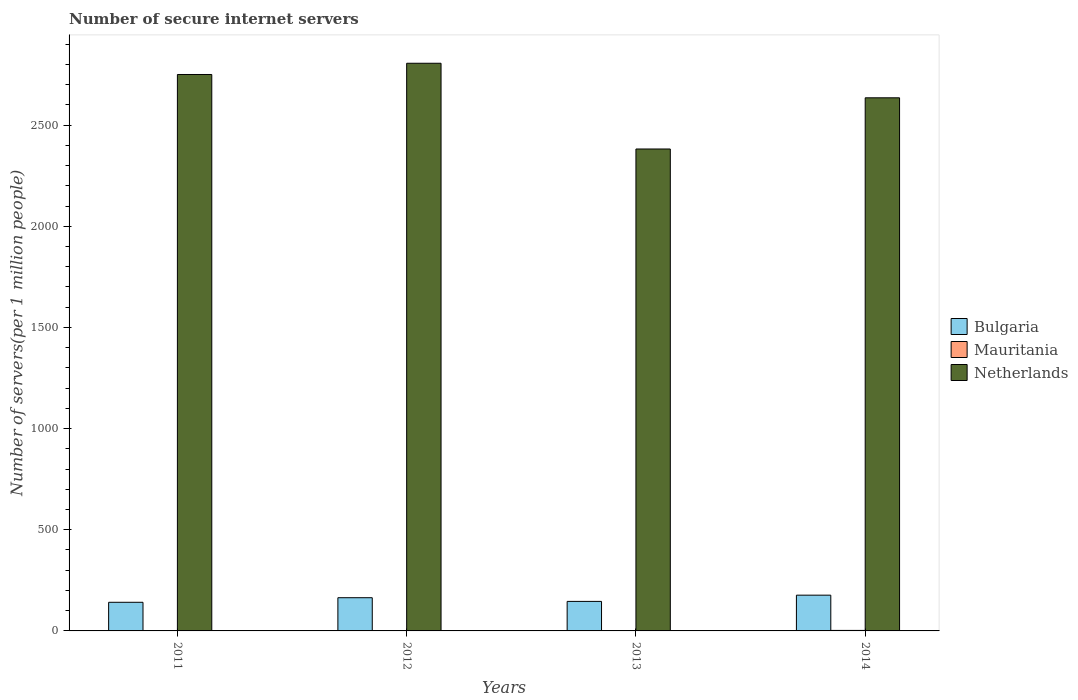How many different coloured bars are there?
Your answer should be very brief. 3. How many bars are there on the 4th tick from the left?
Offer a very short reply. 3. What is the number of secure internet servers in Bulgaria in 2014?
Keep it short and to the point. 176.72. Across all years, what is the maximum number of secure internet servers in Bulgaria?
Ensure brevity in your answer.  176.72. Across all years, what is the minimum number of secure internet servers in Bulgaria?
Make the answer very short. 141.53. What is the total number of secure internet servers in Mauritania in the graph?
Offer a terse response. 8.34. What is the difference between the number of secure internet servers in Bulgaria in 2012 and that in 2013?
Give a very brief answer. 18.21. What is the difference between the number of secure internet servers in Netherlands in 2014 and the number of secure internet servers in Mauritania in 2013?
Offer a very short reply. 2633.01. What is the average number of secure internet servers in Bulgaria per year?
Your answer should be compact. 157.07. In the year 2014, what is the difference between the number of secure internet servers in Bulgaria and number of secure internet servers in Netherlands?
Offer a very short reply. -2458.36. In how many years, is the number of secure internet servers in Mauritania greater than 2500?
Provide a short and direct response. 0. What is the ratio of the number of secure internet servers in Mauritania in 2011 to that in 2014?
Provide a succinct answer. 0.75. Is the number of secure internet servers in Bulgaria in 2012 less than that in 2013?
Provide a succinct answer. No. Is the difference between the number of secure internet servers in Bulgaria in 2012 and 2013 greater than the difference between the number of secure internet servers in Netherlands in 2012 and 2013?
Provide a short and direct response. No. What is the difference between the highest and the second highest number of secure internet servers in Mauritania?
Provide a succinct answer. 0.45. What is the difference between the highest and the lowest number of secure internet servers in Bulgaria?
Your answer should be very brief. 35.19. What does the 2nd bar from the left in 2011 represents?
Offer a terse response. Mauritania. What does the 2nd bar from the right in 2011 represents?
Offer a very short reply. Mauritania. Is it the case that in every year, the sum of the number of secure internet servers in Mauritania and number of secure internet servers in Bulgaria is greater than the number of secure internet servers in Netherlands?
Offer a terse response. No. How many bars are there?
Your answer should be very brief. 12. Are all the bars in the graph horizontal?
Keep it short and to the point. No. Does the graph contain any zero values?
Your answer should be compact. No. What is the title of the graph?
Your answer should be compact. Number of secure internet servers. Does "Faeroe Islands" appear as one of the legend labels in the graph?
Offer a terse response. No. What is the label or title of the Y-axis?
Your response must be concise. Number of servers(per 1 million people). What is the Number of servers(per 1 million people) of Bulgaria in 2011?
Make the answer very short. 141.53. What is the Number of servers(per 1 million people) in Mauritania in 2011?
Your response must be concise. 1.9. What is the Number of servers(per 1 million people) in Netherlands in 2011?
Make the answer very short. 2750.3. What is the Number of servers(per 1 million people) in Bulgaria in 2012?
Offer a terse response. 164.11. What is the Number of servers(per 1 million people) of Mauritania in 2012?
Provide a succinct answer. 1.85. What is the Number of servers(per 1 million people) of Netherlands in 2012?
Your response must be concise. 2805.86. What is the Number of servers(per 1 million people) of Bulgaria in 2013?
Your answer should be compact. 145.9. What is the Number of servers(per 1 million people) of Mauritania in 2013?
Your answer should be very brief. 2.07. What is the Number of servers(per 1 million people) of Netherlands in 2013?
Your answer should be compact. 2382.11. What is the Number of servers(per 1 million people) of Bulgaria in 2014?
Give a very brief answer. 176.72. What is the Number of servers(per 1 million people) of Mauritania in 2014?
Provide a succinct answer. 2.52. What is the Number of servers(per 1 million people) of Netherlands in 2014?
Your answer should be compact. 2635.07. Across all years, what is the maximum Number of servers(per 1 million people) in Bulgaria?
Your answer should be very brief. 176.72. Across all years, what is the maximum Number of servers(per 1 million people) of Mauritania?
Offer a terse response. 2.52. Across all years, what is the maximum Number of servers(per 1 million people) of Netherlands?
Offer a very short reply. 2805.86. Across all years, what is the minimum Number of servers(per 1 million people) in Bulgaria?
Ensure brevity in your answer.  141.53. Across all years, what is the minimum Number of servers(per 1 million people) in Mauritania?
Make the answer very short. 1.85. Across all years, what is the minimum Number of servers(per 1 million people) of Netherlands?
Give a very brief answer. 2382.11. What is the total Number of servers(per 1 million people) in Bulgaria in the graph?
Your answer should be compact. 628.26. What is the total Number of servers(per 1 million people) of Mauritania in the graph?
Keep it short and to the point. 8.34. What is the total Number of servers(per 1 million people) in Netherlands in the graph?
Provide a short and direct response. 1.06e+04. What is the difference between the Number of servers(per 1 million people) in Bulgaria in 2011 and that in 2012?
Ensure brevity in your answer.  -22.59. What is the difference between the Number of servers(per 1 million people) in Mauritania in 2011 and that in 2012?
Your answer should be compact. 0.05. What is the difference between the Number of servers(per 1 million people) in Netherlands in 2011 and that in 2012?
Offer a very short reply. -55.55. What is the difference between the Number of servers(per 1 million people) of Bulgaria in 2011 and that in 2013?
Your answer should be compact. -4.37. What is the difference between the Number of servers(per 1 million people) in Mauritania in 2011 and that in 2013?
Keep it short and to the point. -0.17. What is the difference between the Number of servers(per 1 million people) of Netherlands in 2011 and that in 2013?
Keep it short and to the point. 368.19. What is the difference between the Number of servers(per 1 million people) of Bulgaria in 2011 and that in 2014?
Provide a succinct answer. -35.19. What is the difference between the Number of servers(per 1 million people) of Mauritania in 2011 and that in 2014?
Your response must be concise. -0.62. What is the difference between the Number of servers(per 1 million people) in Netherlands in 2011 and that in 2014?
Provide a succinct answer. 115.23. What is the difference between the Number of servers(per 1 million people) of Bulgaria in 2012 and that in 2013?
Provide a succinct answer. 18.21. What is the difference between the Number of servers(per 1 million people) in Mauritania in 2012 and that in 2013?
Ensure brevity in your answer.  -0.21. What is the difference between the Number of servers(per 1 million people) in Netherlands in 2012 and that in 2013?
Offer a very short reply. 423.75. What is the difference between the Number of servers(per 1 million people) of Bulgaria in 2012 and that in 2014?
Provide a succinct answer. -12.6. What is the difference between the Number of servers(per 1 million people) of Mauritania in 2012 and that in 2014?
Give a very brief answer. -0.67. What is the difference between the Number of servers(per 1 million people) in Netherlands in 2012 and that in 2014?
Offer a terse response. 170.78. What is the difference between the Number of servers(per 1 million people) in Bulgaria in 2013 and that in 2014?
Provide a short and direct response. -30.81. What is the difference between the Number of servers(per 1 million people) in Mauritania in 2013 and that in 2014?
Give a very brief answer. -0.45. What is the difference between the Number of servers(per 1 million people) of Netherlands in 2013 and that in 2014?
Make the answer very short. -252.96. What is the difference between the Number of servers(per 1 million people) in Bulgaria in 2011 and the Number of servers(per 1 million people) in Mauritania in 2012?
Give a very brief answer. 139.68. What is the difference between the Number of servers(per 1 million people) in Bulgaria in 2011 and the Number of servers(per 1 million people) in Netherlands in 2012?
Keep it short and to the point. -2664.33. What is the difference between the Number of servers(per 1 million people) of Mauritania in 2011 and the Number of servers(per 1 million people) of Netherlands in 2012?
Provide a short and direct response. -2803.95. What is the difference between the Number of servers(per 1 million people) of Bulgaria in 2011 and the Number of servers(per 1 million people) of Mauritania in 2013?
Offer a terse response. 139.46. What is the difference between the Number of servers(per 1 million people) of Bulgaria in 2011 and the Number of servers(per 1 million people) of Netherlands in 2013?
Provide a short and direct response. -2240.58. What is the difference between the Number of servers(per 1 million people) in Mauritania in 2011 and the Number of servers(per 1 million people) in Netherlands in 2013?
Your answer should be compact. -2380.21. What is the difference between the Number of servers(per 1 million people) of Bulgaria in 2011 and the Number of servers(per 1 million people) of Mauritania in 2014?
Provide a succinct answer. 139.01. What is the difference between the Number of servers(per 1 million people) of Bulgaria in 2011 and the Number of servers(per 1 million people) of Netherlands in 2014?
Your answer should be very brief. -2493.54. What is the difference between the Number of servers(per 1 million people) of Mauritania in 2011 and the Number of servers(per 1 million people) of Netherlands in 2014?
Ensure brevity in your answer.  -2633.17. What is the difference between the Number of servers(per 1 million people) in Bulgaria in 2012 and the Number of servers(per 1 million people) in Mauritania in 2013?
Your answer should be compact. 162.05. What is the difference between the Number of servers(per 1 million people) of Bulgaria in 2012 and the Number of servers(per 1 million people) of Netherlands in 2013?
Keep it short and to the point. -2218. What is the difference between the Number of servers(per 1 million people) of Mauritania in 2012 and the Number of servers(per 1 million people) of Netherlands in 2013?
Your answer should be very brief. -2380.26. What is the difference between the Number of servers(per 1 million people) of Bulgaria in 2012 and the Number of servers(per 1 million people) of Mauritania in 2014?
Offer a terse response. 161.6. What is the difference between the Number of servers(per 1 million people) in Bulgaria in 2012 and the Number of servers(per 1 million people) in Netherlands in 2014?
Make the answer very short. -2470.96. What is the difference between the Number of servers(per 1 million people) in Mauritania in 2012 and the Number of servers(per 1 million people) in Netherlands in 2014?
Ensure brevity in your answer.  -2633.22. What is the difference between the Number of servers(per 1 million people) of Bulgaria in 2013 and the Number of servers(per 1 million people) of Mauritania in 2014?
Your response must be concise. 143.38. What is the difference between the Number of servers(per 1 million people) in Bulgaria in 2013 and the Number of servers(per 1 million people) in Netherlands in 2014?
Offer a terse response. -2489.17. What is the difference between the Number of servers(per 1 million people) of Mauritania in 2013 and the Number of servers(per 1 million people) of Netherlands in 2014?
Ensure brevity in your answer.  -2633.01. What is the average Number of servers(per 1 million people) in Bulgaria per year?
Offer a very short reply. 157.07. What is the average Number of servers(per 1 million people) in Mauritania per year?
Your response must be concise. 2.08. What is the average Number of servers(per 1 million people) in Netherlands per year?
Your answer should be compact. 2643.34. In the year 2011, what is the difference between the Number of servers(per 1 million people) of Bulgaria and Number of servers(per 1 million people) of Mauritania?
Keep it short and to the point. 139.63. In the year 2011, what is the difference between the Number of servers(per 1 million people) of Bulgaria and Number of servers(per 1 million people) of Netherlands?
Give a very brief answer. -2608.77. In the year 2011, what is the difference between the Number of servers(per 1 million people) of Mauritania and Number of servers(per 1 million people) of Netherlands?
Your answer should be compact. -2748.4. In the year 2012, what is the difference between the Number of servers(per 1 million people) of Bulgaria and Number of servers(per 1 million people) of Mauritania?
Ensure brevity in your answer.  162.26. In the year 2012, what is the difference between the Number of servers(per 1 million people) of Bulgaria and Number of servers(per 1 million people) of Netherlands?
Provide a short and direct response. -2641.74. In the year 2012, what is the difference between the Number of servers(per 1 million people) of Mauritania and Number of servers(per 1 million people) of Netherlands?
Offer a terse response. -2804. In the year 2013, what is the difference between the Number of servers(per 1 million people) of Bulgaria and Number of servers(per 1 million people) of Mauritania?
Provide a succinct answer. 143.84. In the year 2013, what is the difference between the Number of servers(per 1 million people) of Bulgaria and Number of servers(per 1 million people) of Netherlands?
Ensure brevity in your answer.  -2236.21. In the year 2013, what is the difference between the Number of servers(per 1 million people) of Mauritania and Number of servers(per 1 million people) of Netherlands?
Provide a succinct answer. -2380.04. In the year 2014, what is the difference between the Number of servers(per 1 million people) of Bulgaria and Number of servers(per 1 million people) of Mauritania?
Ensure brevity in your answer.  174.2. In the year 2014, what is the difference between the Number of servers(per 1 million people) of Bulgaria and Number of servers(per 1 million people) of Netherlands?
Offer a terse response. -2458.36. In the year 2014, what is the difference between the Number of servers(per 1 million people) of Mauritania and Number of servers(per 1 million people) of Netherlands?
Offer a terse response. -2632.55. What is the ratio of the Number of servers(per 1 million people) of Bulgaria in 2011 to that in 2012?
Provide a succinct answer. 0.86. What is the ratio of the Number of servers(per 1 million people) of Mauritania in 2011 to that in 2012?
Provide a succinct answer. 1.03. What is the ratio of the Number of servers(per 1 million people) in Netherlands in 2011 to that in 2012?
Keep it short and to the point. 0.98. What is the ratio of the Number of servers(per 1 million people) of Mauritania in 2011 to that in 2013?
Your answer should be very brief. 0.92. What is the ratio of the Number of servers(per 1 million people) of Netherlands in 2011 to that in 2013?
Ensure brevity in your answer.  1.15. What is the ratio of the Number of servers(per 1 million people) in Bulgaria in 2011 to that in 2014?
Your response must be concise. 0.8. What is the ratio of the Number of servers(per 1 million people) in Mauritania in 2011 to that in 2014?
Provide a succinct answer. 0.75. What is the ratio of the Number of servers(per 1 million people) in Netherlands in 2011 to that in 2014?
Provide a succinct answer. 1.04. What is the ratio of the Number of servers(per 1 million people) of Bulgaria in 2012 to that in 2013?
Offer a terse response. 1.12. What is the ratio of the Number of servers(per 1 million people) in Mauritania in 2012 to that in 2013?
Provide a short and direct response. 0.9. What is the ratio of the Number of servers(per 1 million people) in Netherlands in 2012 to that in 2013?
Ensure brevity in your answer.  1.18. What is the ratio of the Number of servers(per 1 million people) of Bulgaria in 2012 to that in 2014?
Your answer should be very brief. 0.93. What is the ratio of the Number of servers(per 1 million people) in Mauritania in 2012 to that in 2014?
Your response must be concise. 0.74. What is the ratio of the Number of servers(per 1 million people) in Netherlands in 2012 to that in 2014?
Your answer should be compact. 1.06. What is the ratio of the Number of servers(per 1 million people) in Bulgaria in 2013 to that in 2014?
Make the answer very short. 0.83. What is the ratio of the Number of servers(per 1 million people) in Mauritania in 2013 to that in 2014?
Make the answer very short. 0.82. What is the ratio of the Number of servers(per 1 million people) of Netherlands in 2013 to that in 2014?
Your response must be concise. 0.9. What is the difference between the highest and the second highest Number of servers(per 1 million people) in Bulgaria?
Give a very brief answer. 12.6. What is the difference between the highest and the second highest Number of servers(per 1 million people) of Mauritania?
Your answer should be compact. 0.45. What is the difference between the highest and the second highest Number of servers(per 1 million people) of Netherlands?
Ensure brevity in your answer.  55.55. What is the difference between the highest and the lowest Number of servers(per 1 million people) in Bulgaria?
Give a very brief answer. 35.19. What is the difference between the highest and the lowest Number of servers(per 1 million people) in Mauritania?
Provide a succinct answer. 0.67. What is the difference between the highest and the lowest Number of servers(per 1 million people) of Netherlands?
Your answer should be very brief. 423.75. 